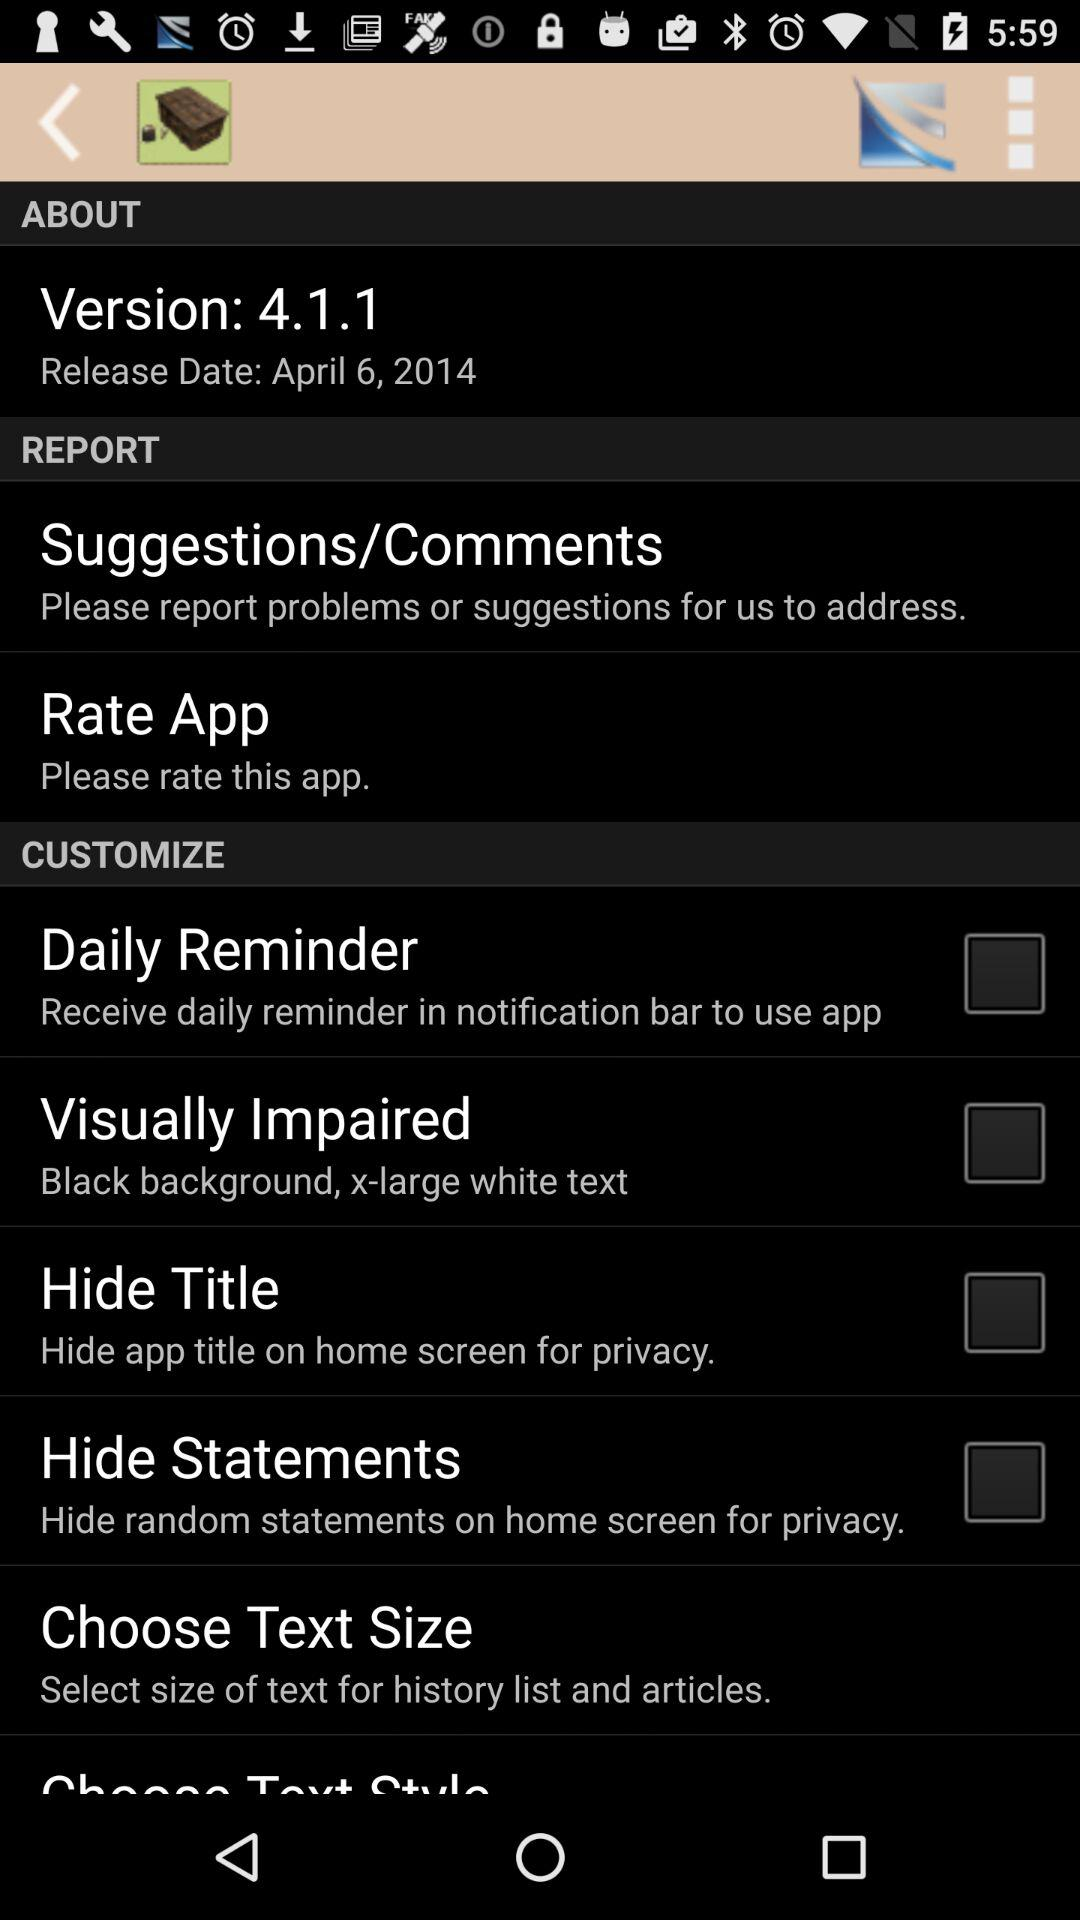What is the status of "Daily Reminder"? The status is "off". 